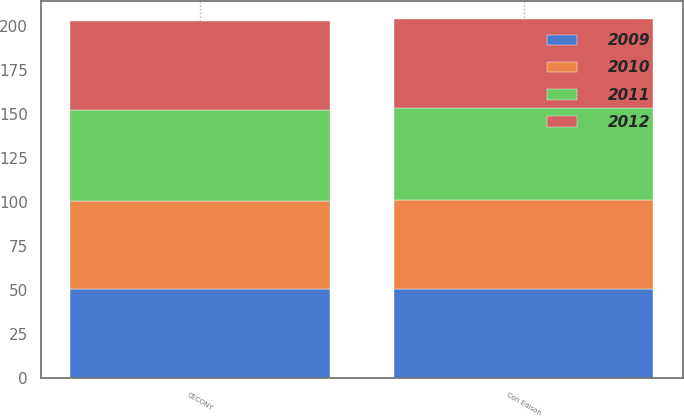Convert chart. <chart><loc_0><loc_0><loc_500><loc_500><stacked_bar_chart><ecel><fcel>Con Edison<fcel>CECONY<nl><fcel>2009<fcel>50.7<fcel>50.8<nl><fcel>2012<fcel>50.5<fcel>50.3<nl><fcel>2010<fcel>50.4<fcel>49.9<nl><fcel>2011<fcel>52.5<fcel>52<nl></chart> 